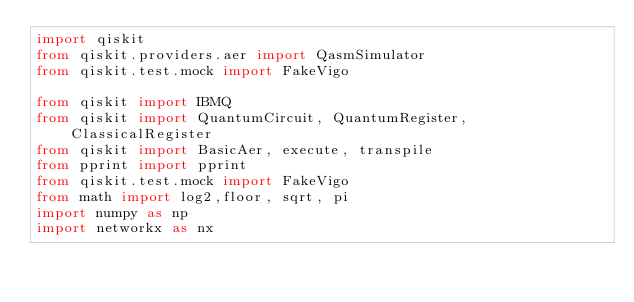<code> <loc_0><loc_0><loc_500><loc_500><_Python_>import qiskit
from qiskit.providers.aer import QasmSimulator
from qiskit.test.mock import FakeVigo

from qiskit import IBMQ
from qiskit import QuantumCircuit, QuantumRegister, ClassicalRegister
from qiskit import BasicAer, execute, transpile
from pprint import pprint
from qiskit.test.mock import FakeVigo
from math import log2,floor, sqrt, pi
import numpy as np
import networkx as nx
</code> 